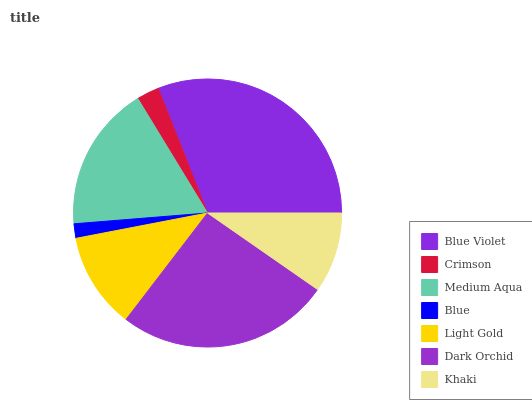Is Blue the minimum?
Answer yes or no. Yes. Is Blue Violet the maximum?
Answer yes or no. Yes. Is Crimson the minimum?
Answer yes or no. No. Is Crimson the maximum?
Answer yes or no. No. Is Blue Violet greater than Crimson?
Answer yes or no. Yes. Is Crimson less than Blue Violet?
Answer yes or no. Yes. Is Crimson greater than Blue Violet?
Answer yes or no. No. Is Blue Violet less than Crimson?
Answer yes or no. No. Is Light Gold the high median?
Answer yes or no. Yes. Is Light Gold the low median?
Answer yes or no. Yes. Is Medium Aqua the high median?
Answer yes or no. No. Is Crimson the low median?
Answer yes or no. No. 